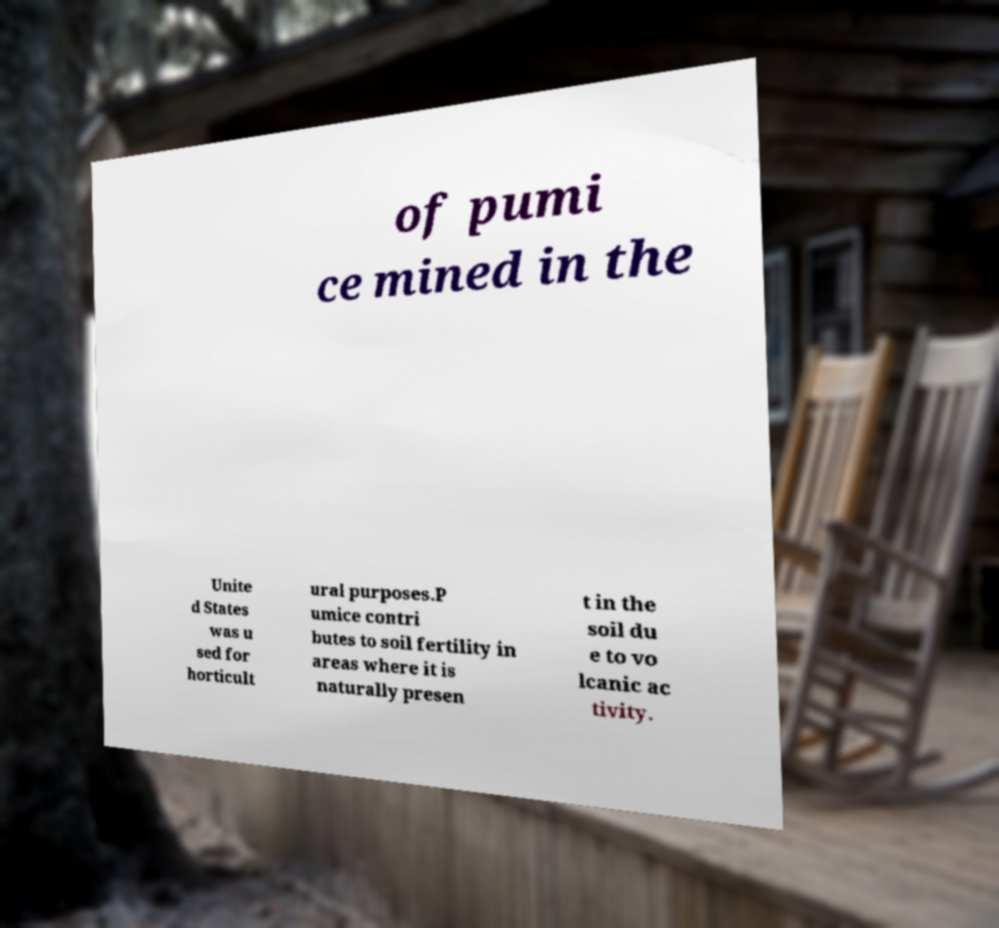Could you assist in decoding the text presented in this image and type it out clearly? of pumi ce mined in the Unite d States was u sed for horticult ural purposes.P umice contri butes to soil fertility in areas where it is naturally presen t in the soil du e to vo lcanic ac tivity. 